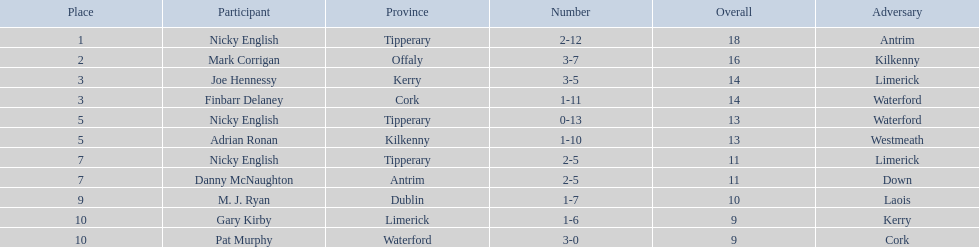Who are all the players? Nicky English, Mark Corrigan, Joe Hennessy, Finbarr Delaney, Nicky English, Adrian Ronan, Nicky English, Danny McNaughton, M. J. Ryan, Gary Kirby, Pat Murphy. How many points did they receive? 18, 16, 14, 14, 13, 13, 11, 11, 10, 9, 9. And which player received 10 points? M. J. Ryan. 